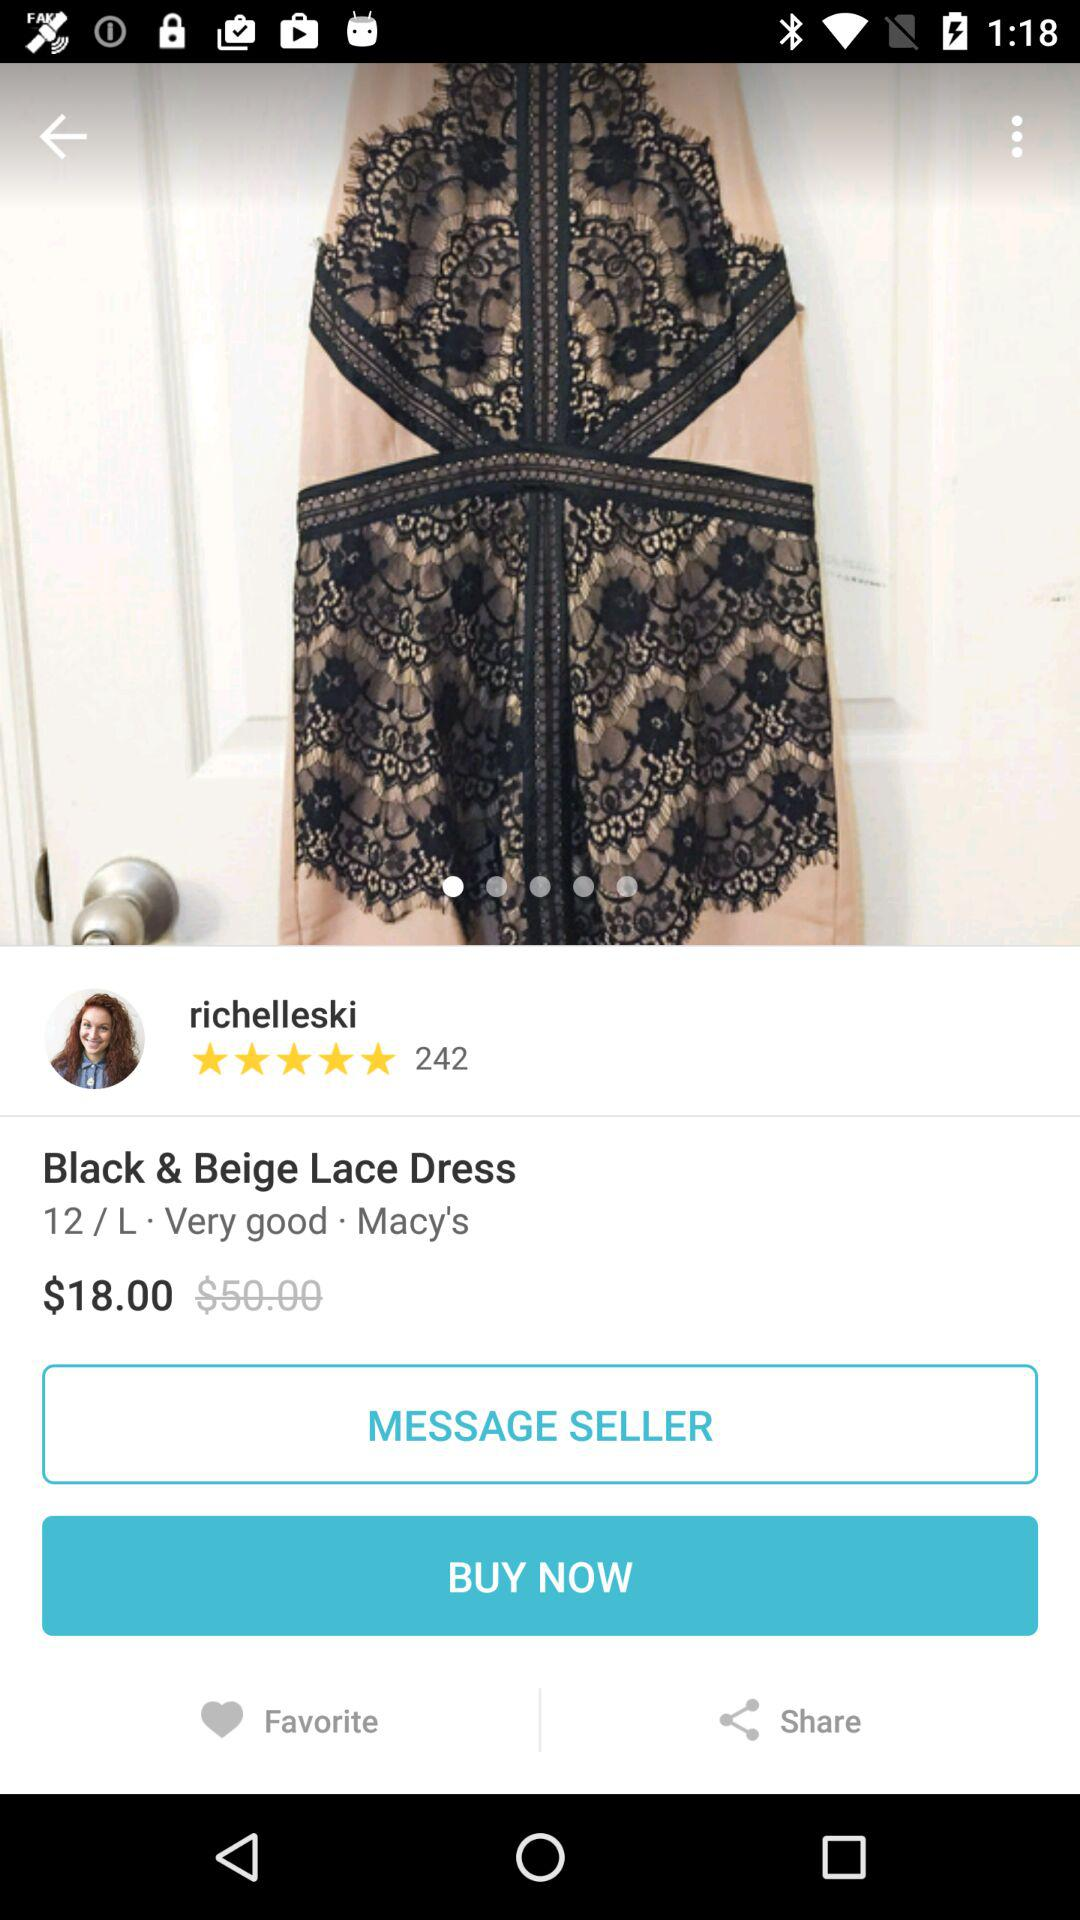Which applications are available for sharing the lace dress?
When the provided information is insufficient, respond with <no answer>. <no answer> 